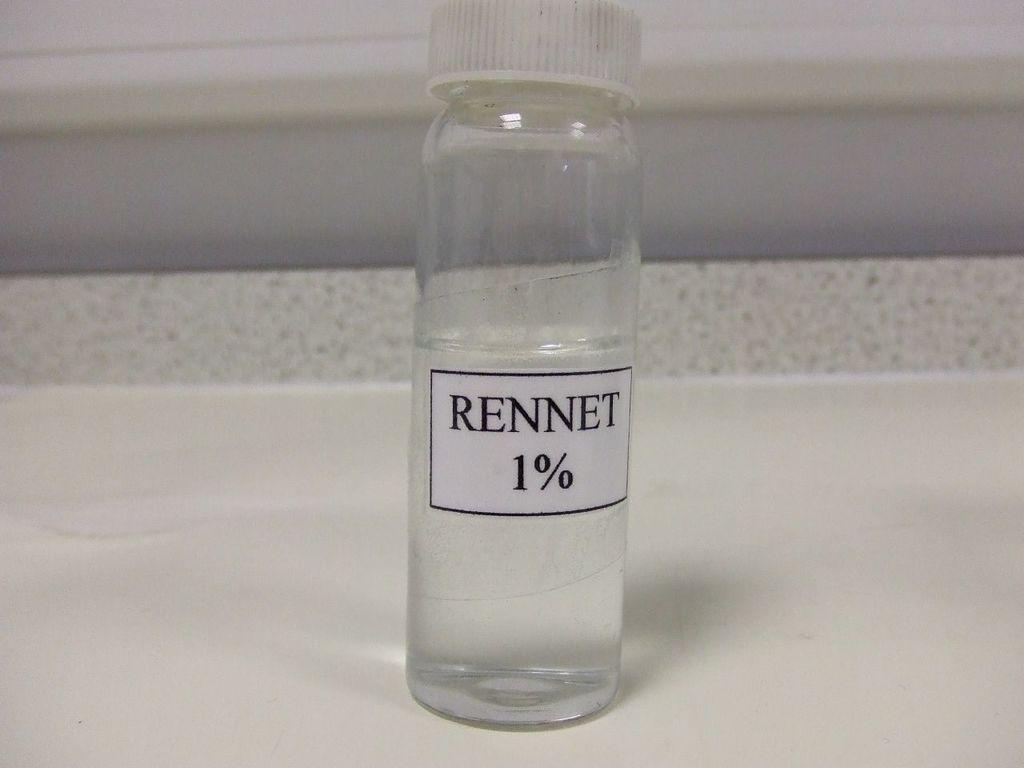Can you describe this image briefly? In this image I can see a white color bottle, a white color sticker is attached to this bottle and on that I can see a word RENNET. 